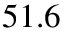<formula> <loc_0><loc_0><loc_500><loc_500>5 1 . 6</formula> 